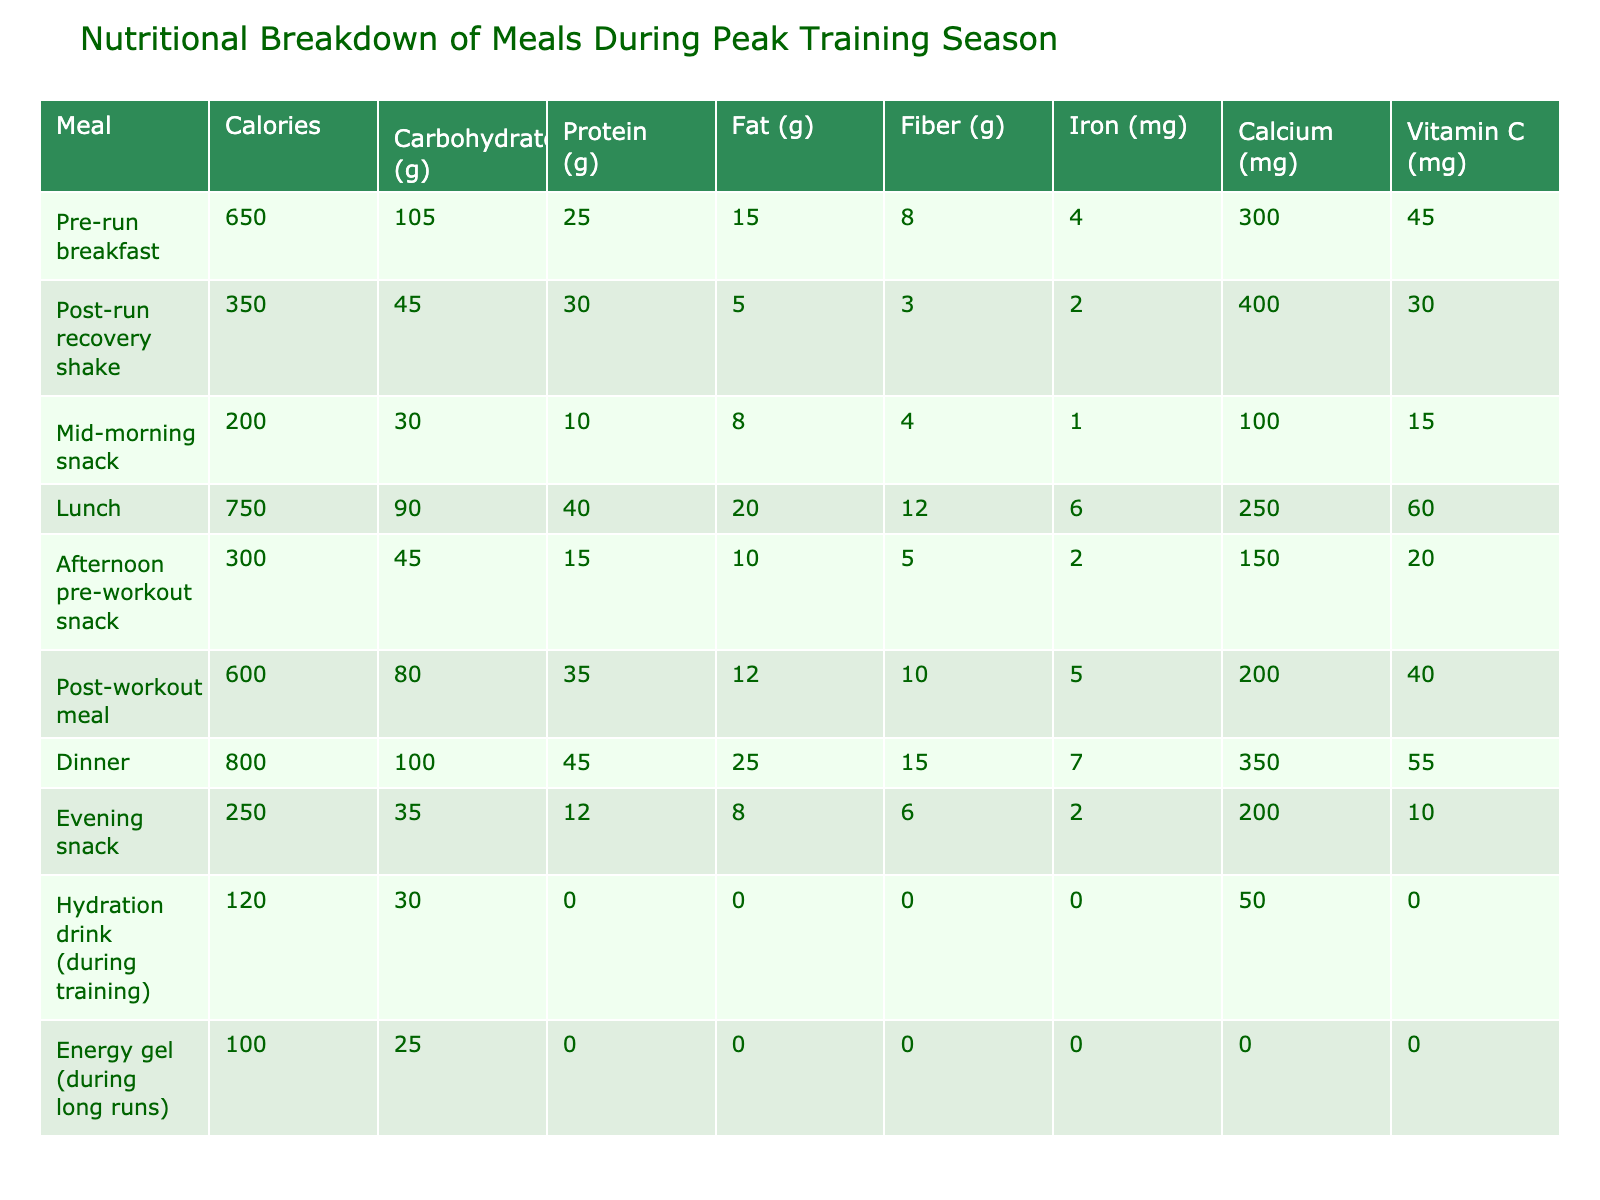What is the total calorie intake from lunch and dinner? Lunch has 750 calories and dinner has 800 calories. Adding these together gives 750 + 800 = 1550 calories.
Answer: 1550 What meal has the highest protein content? Lunch has 40 grams of protein, dinner has 45 grams, and no other meal exceeds this amount. Therefore, dinner has the highest protein content.
Answer: Dinner Is the fat content in the post-workout meal higher than that in the mid-morning snack? The post-workout meal contains 12 grams of fat, while the mid-morning snack contains 8 grams. Since 12 is greater than 8, the post-workout meal has higher fat content.
Answer: Yes What is the average carbohydrate content per meal? The total carbohydrate content is 105 + 45 + 30 + 90 + 45 + 80 + 100 + 35 + 30 + 25 =  585 grams. There are 10 meals total, so the average is 585/10 = 58.5 grams.
Answer: 58.5 Which meal delivers the least amount of calcium? The mid-morning snack has 100 mg of calcium, which is less than all other meals listed.
Answer: Mid-morning snack How many grams of fiber does the pre-run breakfast have compared to the post-run recovery shake? The pre-run breakfast has 8 grams of fiber while the post-run recovery shake has 3 grams. The pre-run breakfast has 8 - 3 = 5 grams more fiber than the shake.
Answer: 5 grams more Based on the data, what percentage of total calories is provided by the dinner meal? The total calories for all meals is 650 + 350 + 200 + 750 + 300 + 600 + 800 + 250 + 120 + 100 = 4100 calories. Dinner provides 800 calories, so the percentage is (800 / 4100) * 100 = 19.51%.
Answer: 19.51% What is the difference in iron content between lunch and post-workout meal? Lunch has 6 mg of iron, and the post-workout meal has 5 mg of iron. The difference is 6 - 5 = 1 mg.
Answer: 1 mg Do any meals provide vitamin C higher than 50 mg? The lunch meal provides 60 mg of vitamin C, which is higher than 50 mg, confirming that it meets the criteria.
Answer: Yes What is the combined total calories from the hydration drink and energy gel? The hydration drink has 120 calories and the energy gel has 100 calories. The total is 120 + 100 = 220 calories.
Answer: 220 